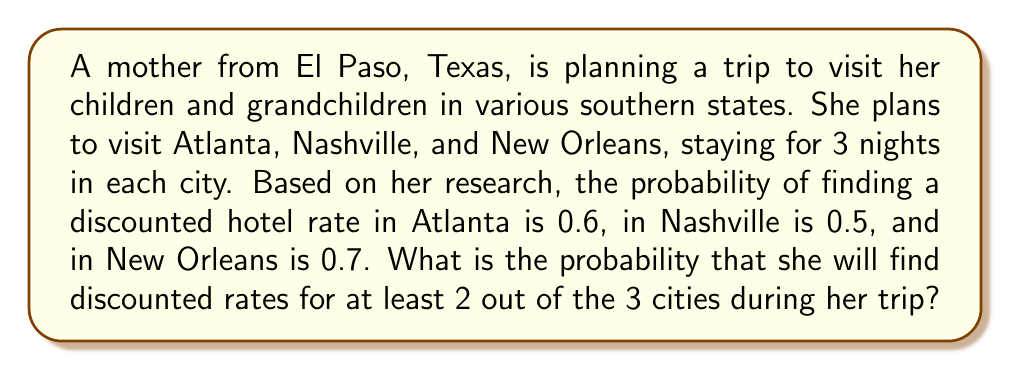What is the answer to this math problem? To solve this problem, we can use the concept of binomial probability. We need to calculate the probability of finding discounted rates in exactly 2 cities or in all 3 cities.

Let's break it down step by step:

1. Probability of success (finding a discount) for each city:
   $p_1 = 0.6$ (Atlanta)
   $p_2 = 0.5$ (Nashville)
   $p_3 = 0.7$ (New Orleans)

2. Probability of failure (not finding a discount) for each city:
   $q_1 = 1 - p_1 = 0.4$ (Atlanta)
   $q_2 = 1 - p_2 = 0.5$ (Nashville)
   $q_3 = 1 - p_3 = 0.3$ (New Orleans)

3. Probability of finding discounts in all 3 cities:
   $P(\text{all 3}) = p_1 \times p_2 \times p_3 = 0.6 \times 0.5 \times 0.7 = 0.21$

4. Probability of finding discounts in exactly 2 cities:
   $P(\text{Atlanta and Nashville}) = p_1 \times p_2 \times q_3 = 0.6 \times 0.5 \times 0.3 = 0.09$
   $P(\text{Atlanta and New Orleans}) = p_1 \times q_2 \times p_3 = 0.6 \times 0.5 \times 0.7 = 0.21$
   $P(\text{Nashville and New Orleans}) = q_1 \times p_2 \times p_3 = 0.4 \times 0.5 \times 0.7 = 0.14$

5. Sum the probabilities for at least 2 cities:
   $P(\text{at least 2}) = P(\text{all 3}) + P(\text{exactly 2})$
   $= 0.21 + (0.09 + 0.21 + 0.14)$
   $= 0.21 + 0.44$
   $= 0.65$

Therefore, the probability of finding discounted rates for at least 2 out of the 3 cities during her trip is 0.65 or 65%.
Answer: The probability that the mother will find discounted rates for at least 2 out of the 3 cities during her trip is 0.65 or 65%. 